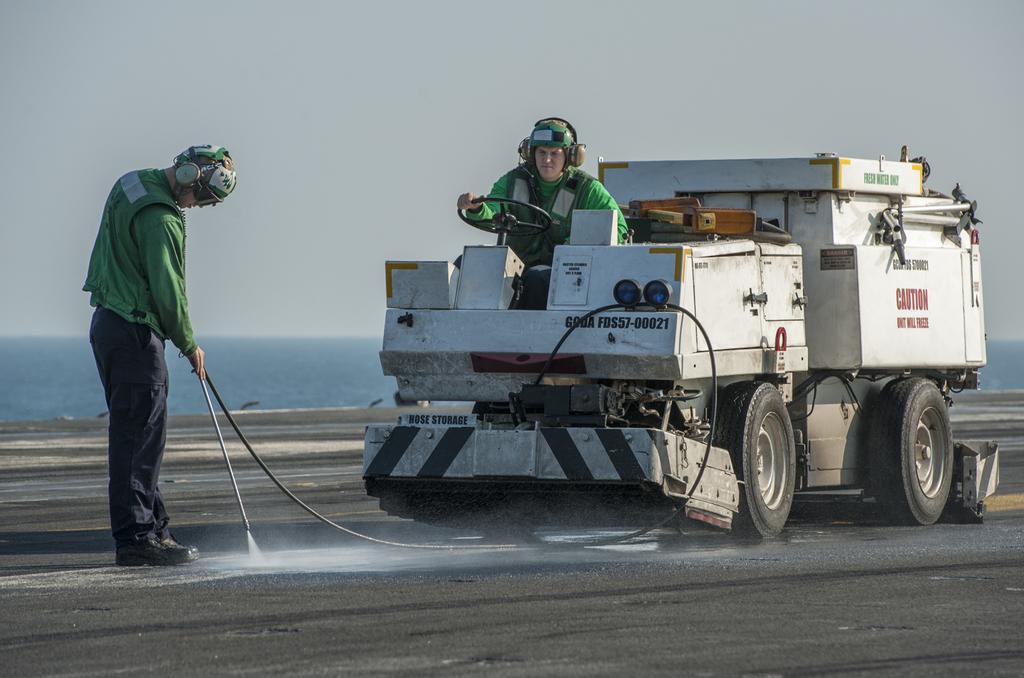Please provide a concise description of this image. In this picture, we see a man who is wearing a green jacket and a helmet is riding a white color vehicle. On the left side, we see a man in the green jacket and a helmet is standing and he is holding a black pipe in his hand. At the bottom, we see the road. In the background, we see water and this water might be in the river. At the top, we see the sky. 